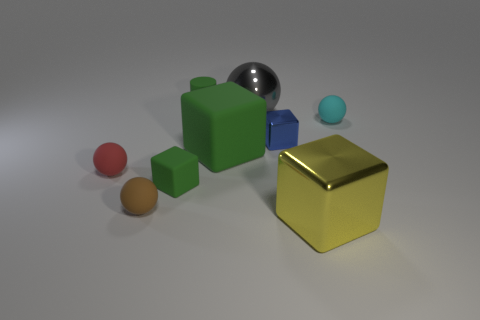Subtract all cylinders. How many objects are left? 8 Add 7 large blocks. How many large blocks are left? 9 Add 4 tiny blue metal cubes. How many tiny blue metal cubes exist? 5 Subtract 0 brown cylinders. How many objects are left? 9 Subtract all matte objects. Subtract all big yellow cubes. How many objects are left? 2 